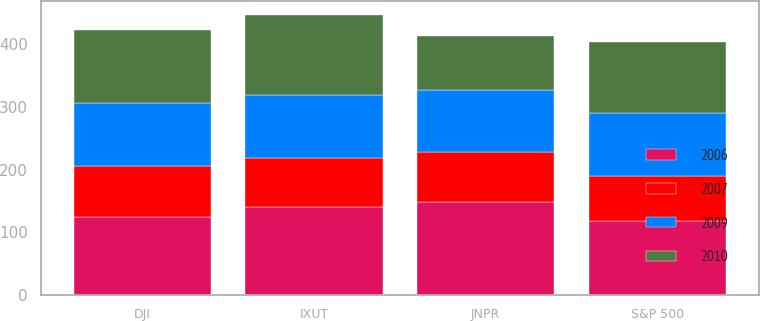Convert chart to OTSL. <chart><loc_0><loc_0><loc_500><loc_500><stacked_bar_chart><ecel><fcel>JNPR<fcel>S&P 500<fcel>DJI<fcel>IXUT<nl><fcel>2009<fcel>100<fcel>100<fcel>100<fcel>100<nl><fcel>2010<fcel>84.93<fcel>113.62<fcel>116.29<fcel>127.76<nl><fcel>2006<fcel>148.88<fcel>117.63<fcel>123.77<fcel>139.48<nl><fcel>2007<fcel>78.52<fcel>72.36<fcel>81.89<fcel>79.53<nl></chart> 